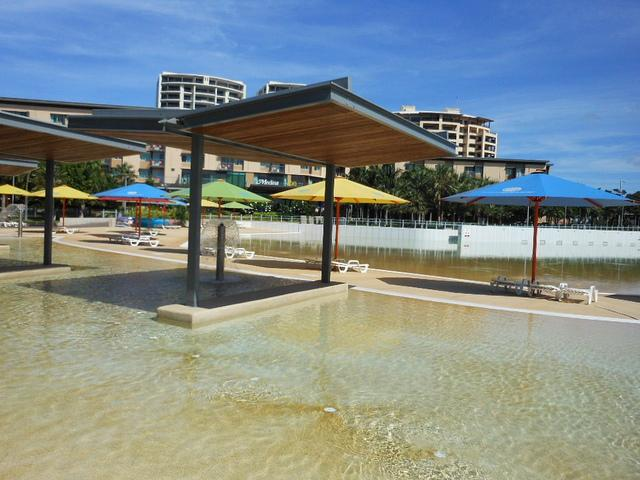This pool is mainly for what swimmers?

Choices:
A) kids
B) experienced swimmers
C) pregnant women
D) elderly people kids 